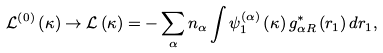<formula> <loc_0><loc_0><loc_500><loc_500>\mathcal { L } ^ { \left ( 0 \right ) } \left ( \kappa \right ) \rightarrow \mathcal { L } \left ( \kappa \right ) = - \sum _ { \alpha } n _ { \alpha } \int \psi _ { 1 } ^ { ( \alpha ) } \left ( \kappa \right ) g _ { \alpha R } ^ { \ast } \left ( r _ { 1 } \right ) d r _ { 1 } ,</formula> 